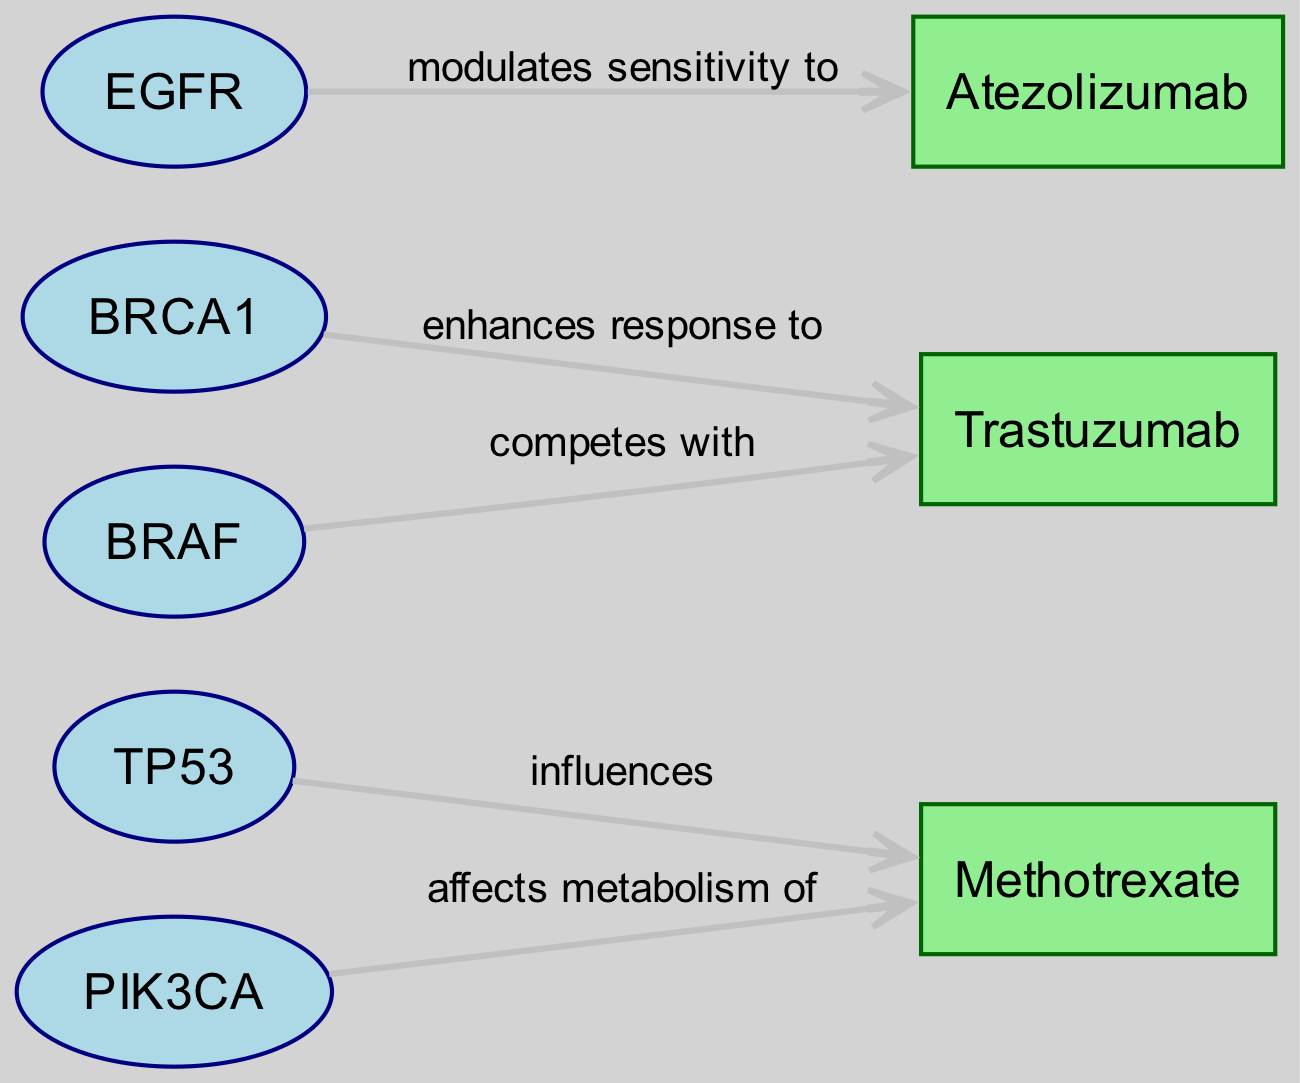What are the total number of nodes in the graph? The graph contains six unique nodes: TP53, BRCA1, EGFR, PIK3CA, BRAF, Methotrexate, Trastuzumab, and Atezolizumab. Counting these, we find there are a total of seven nodes.
Answer: 7 Which gene influences Methotrexate? The diagram shows that the edge directed from TP53 to Methotrexate indicates that TP53 influences Methotrexate.
Answer: TP53 Which relationship does BRCA1 have with Trastuzumab? From the diagram, the edge going from BRCA1 to Trastuzumab is labeled "enhances response to", indicating the type of relationship.
Answer: enhances response to How many edges are present in the graph? By checking the relationships represented by the directed edges leading from genes to drugs, we find there are five edges total: TP53 to Methotrexate, BRCA1 to Trastuzumab, EGFR to Atezolizumab, PIK3CA to Methotrexate, and BRAF to Trastuzumab.
Answer: 5 Which gene competes with Trastuzumab? The edge leading from BRAF to Trastuzumab in the diagram specifies the relationship as "competes with", indicating that BRAF is the gene in question.
Answer: BRAF What is the relationship type between EGFR and Atezolizumab? The directed edge from EGFR to Atezolizumab is labeled "modulates sensitivity to", which details the nature of the interaction.
Answer: modulates sensitivity to Which drug does PIK3CA affect the metabolism of? By examining the edge from PIK3CA that points to Methotrexate, the diagram shows that PIK3CA affects the metabolism of this drug.
Answer: Methotrexate Identify one gene that enhances the response to a drug. The edge from BRCA1 to Trastuzumab clearly states that BRCA1 enhances the response to this drug, providing an example of such a gene in the diagram.
Answer: BRCA1 